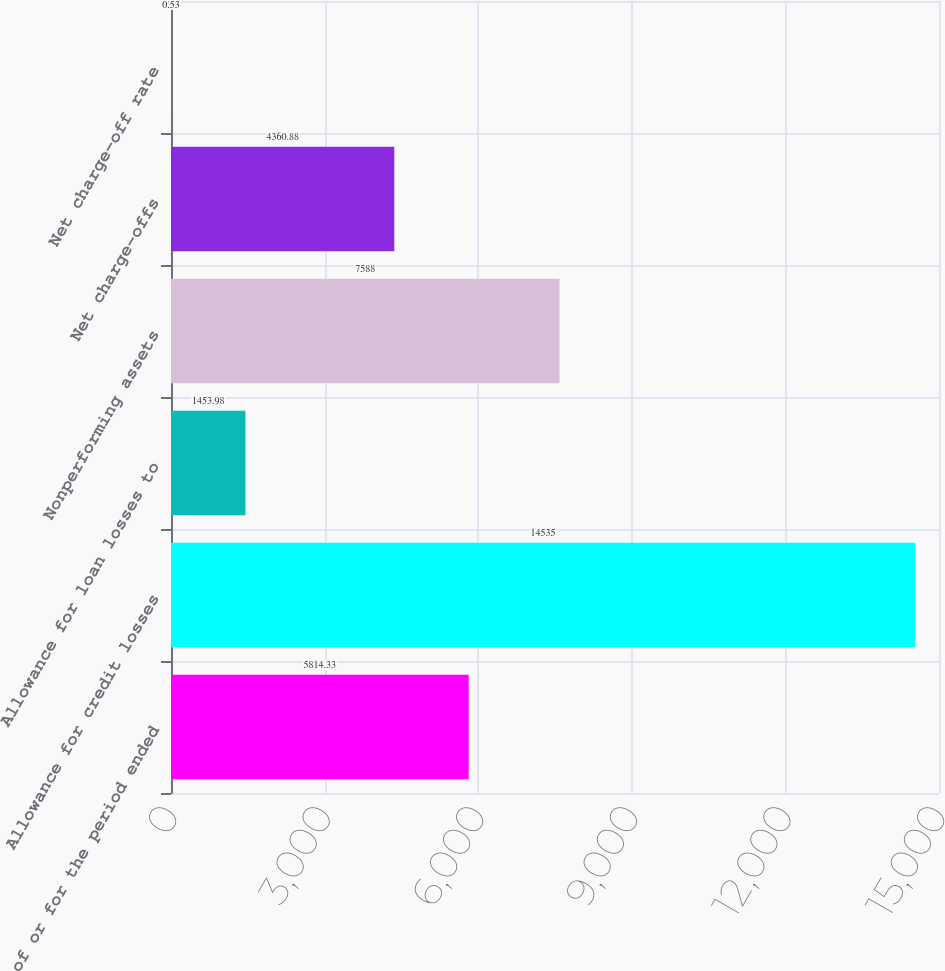<chart> <loc_0><loc_0><loc_500><loc_500><bar_chart><fcel>As of or for the period ended<fcel>Allowance for credit losses<fcel>Allowance for loan losses to<fcel>Nonperforming assets<fcel>Net charge-offs<fcel>Net charge-off rate<nl><fcel>5814.33<fcel>14535<fcel>1453.98<fcel>7588<fcel>4360.88<fcel>0.53<nl></chart> 